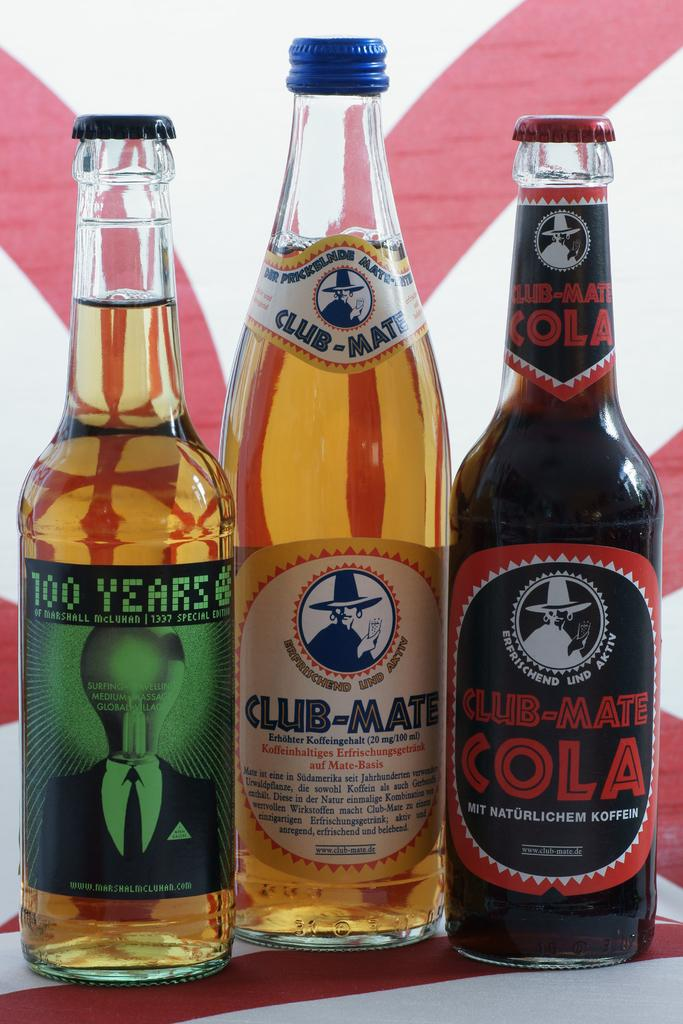How many bottles are visible in the image? There are three bottles in the image. What are the bottles filled with? The bottles are filled with a drink. What type of pickle is growing in the image? There is no pickle present in the image, and therefore no growth can be observed. 